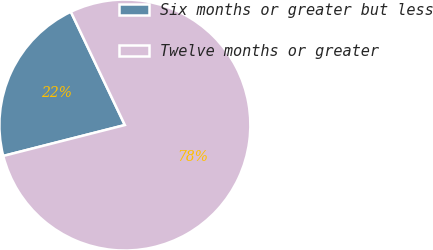Convert chart. <chart><loc_0><loc_0><loc_500><loc_500><pie_chart><fcel>Six months or greater but less<fcel>Twelve months or greater<nl><fcel>21.88%<fcel>78.12%<nl></chart> 